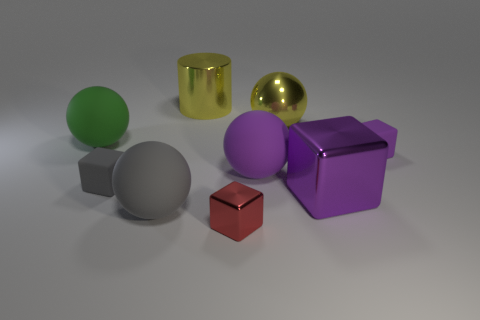Subtract all purple cubes. How many were subtracted if there are1purple cubes left? 1 Subtract all red cylinders. How many purple blocks are left? 2 Subtract all purple balls. How many balls are left? 3 Add 1 large gray matte spheres. How many objects exist? 10 Subtract all gray blocks. How many blocks are left? 3 Subtract all blue spheres. Subtract all gray cylinders. How many spheres are left? 4 Subtract all cubes. How many objects are left? 5 Add 1 big green rubber objects. How many big green rubber objects are left? 2 Add 3 large gray metal cubes. How many large gray metal cubes exist? 3 Subtract 0 green blocks. How many objects are left? 9 